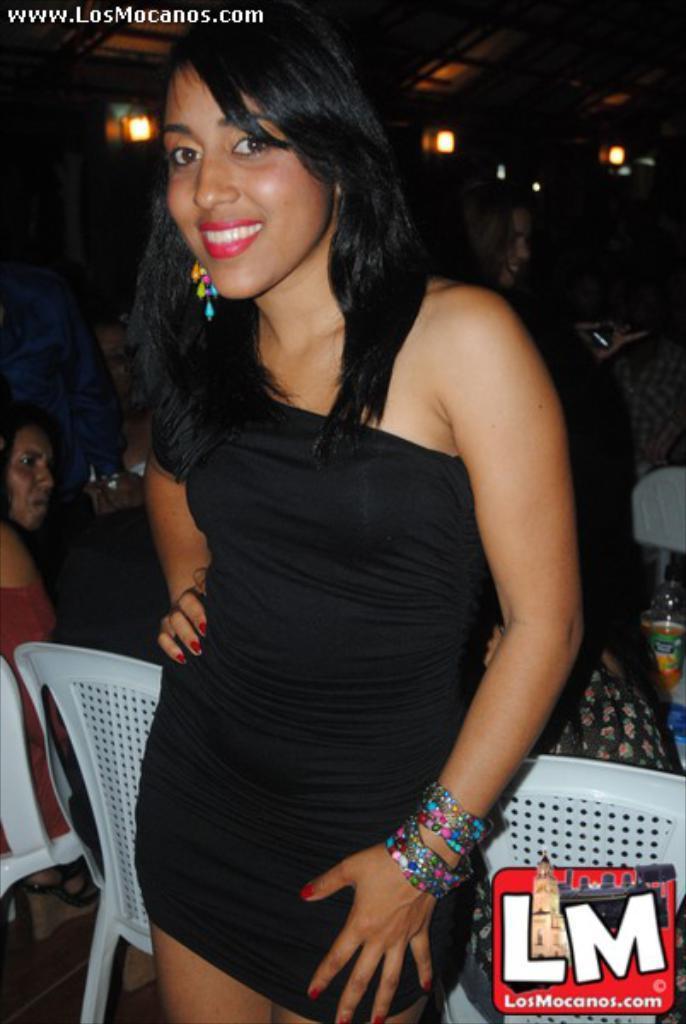How would you summarize this image in a sentence or two? In this a beautiful woman is standing and smiling, she wore black color top, behind there are white color chairs and there are lights at the top. 